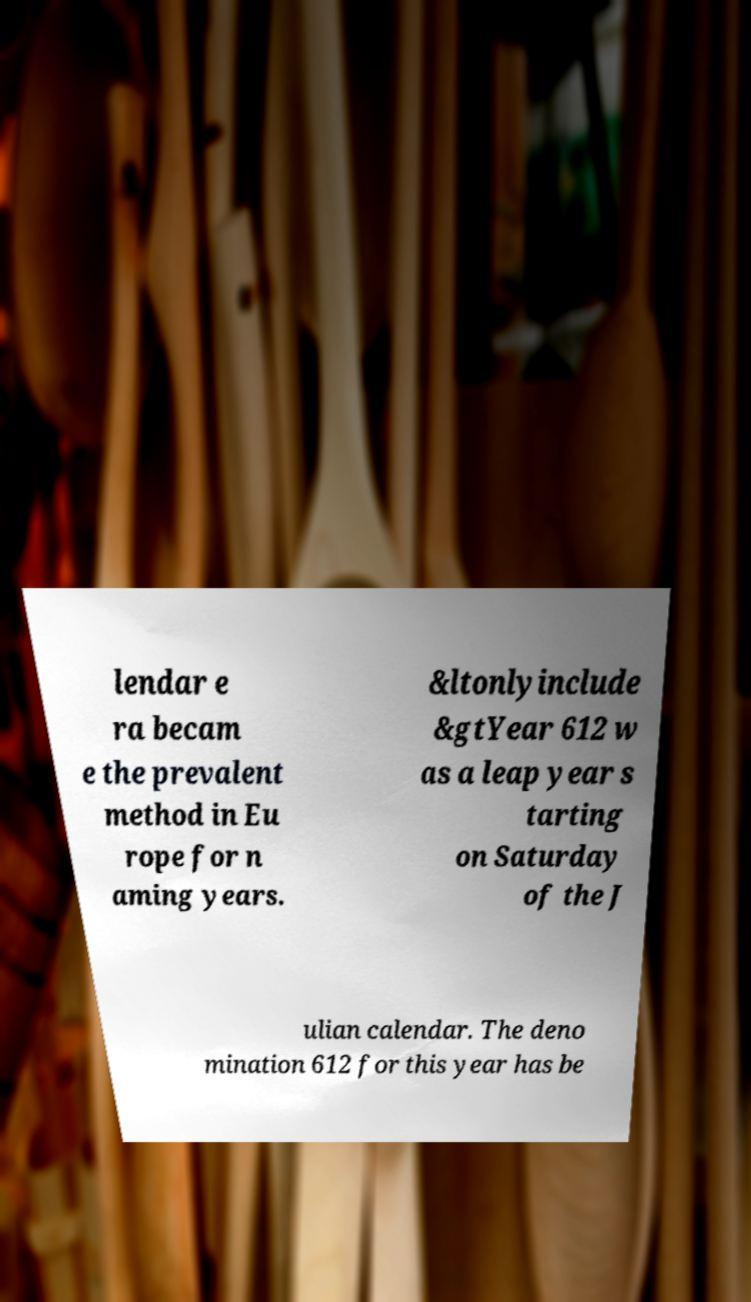For documentation purposes, I need the text within this image transcribed. Could you provide that? lendar e ra becam e the prevalent method in Eu rope for n aming years. &ltonlyinclude &gtYear 612 w as a leap year s tarting on Saturday of the J ulian calendar. The deno mination 612 for this year has be 